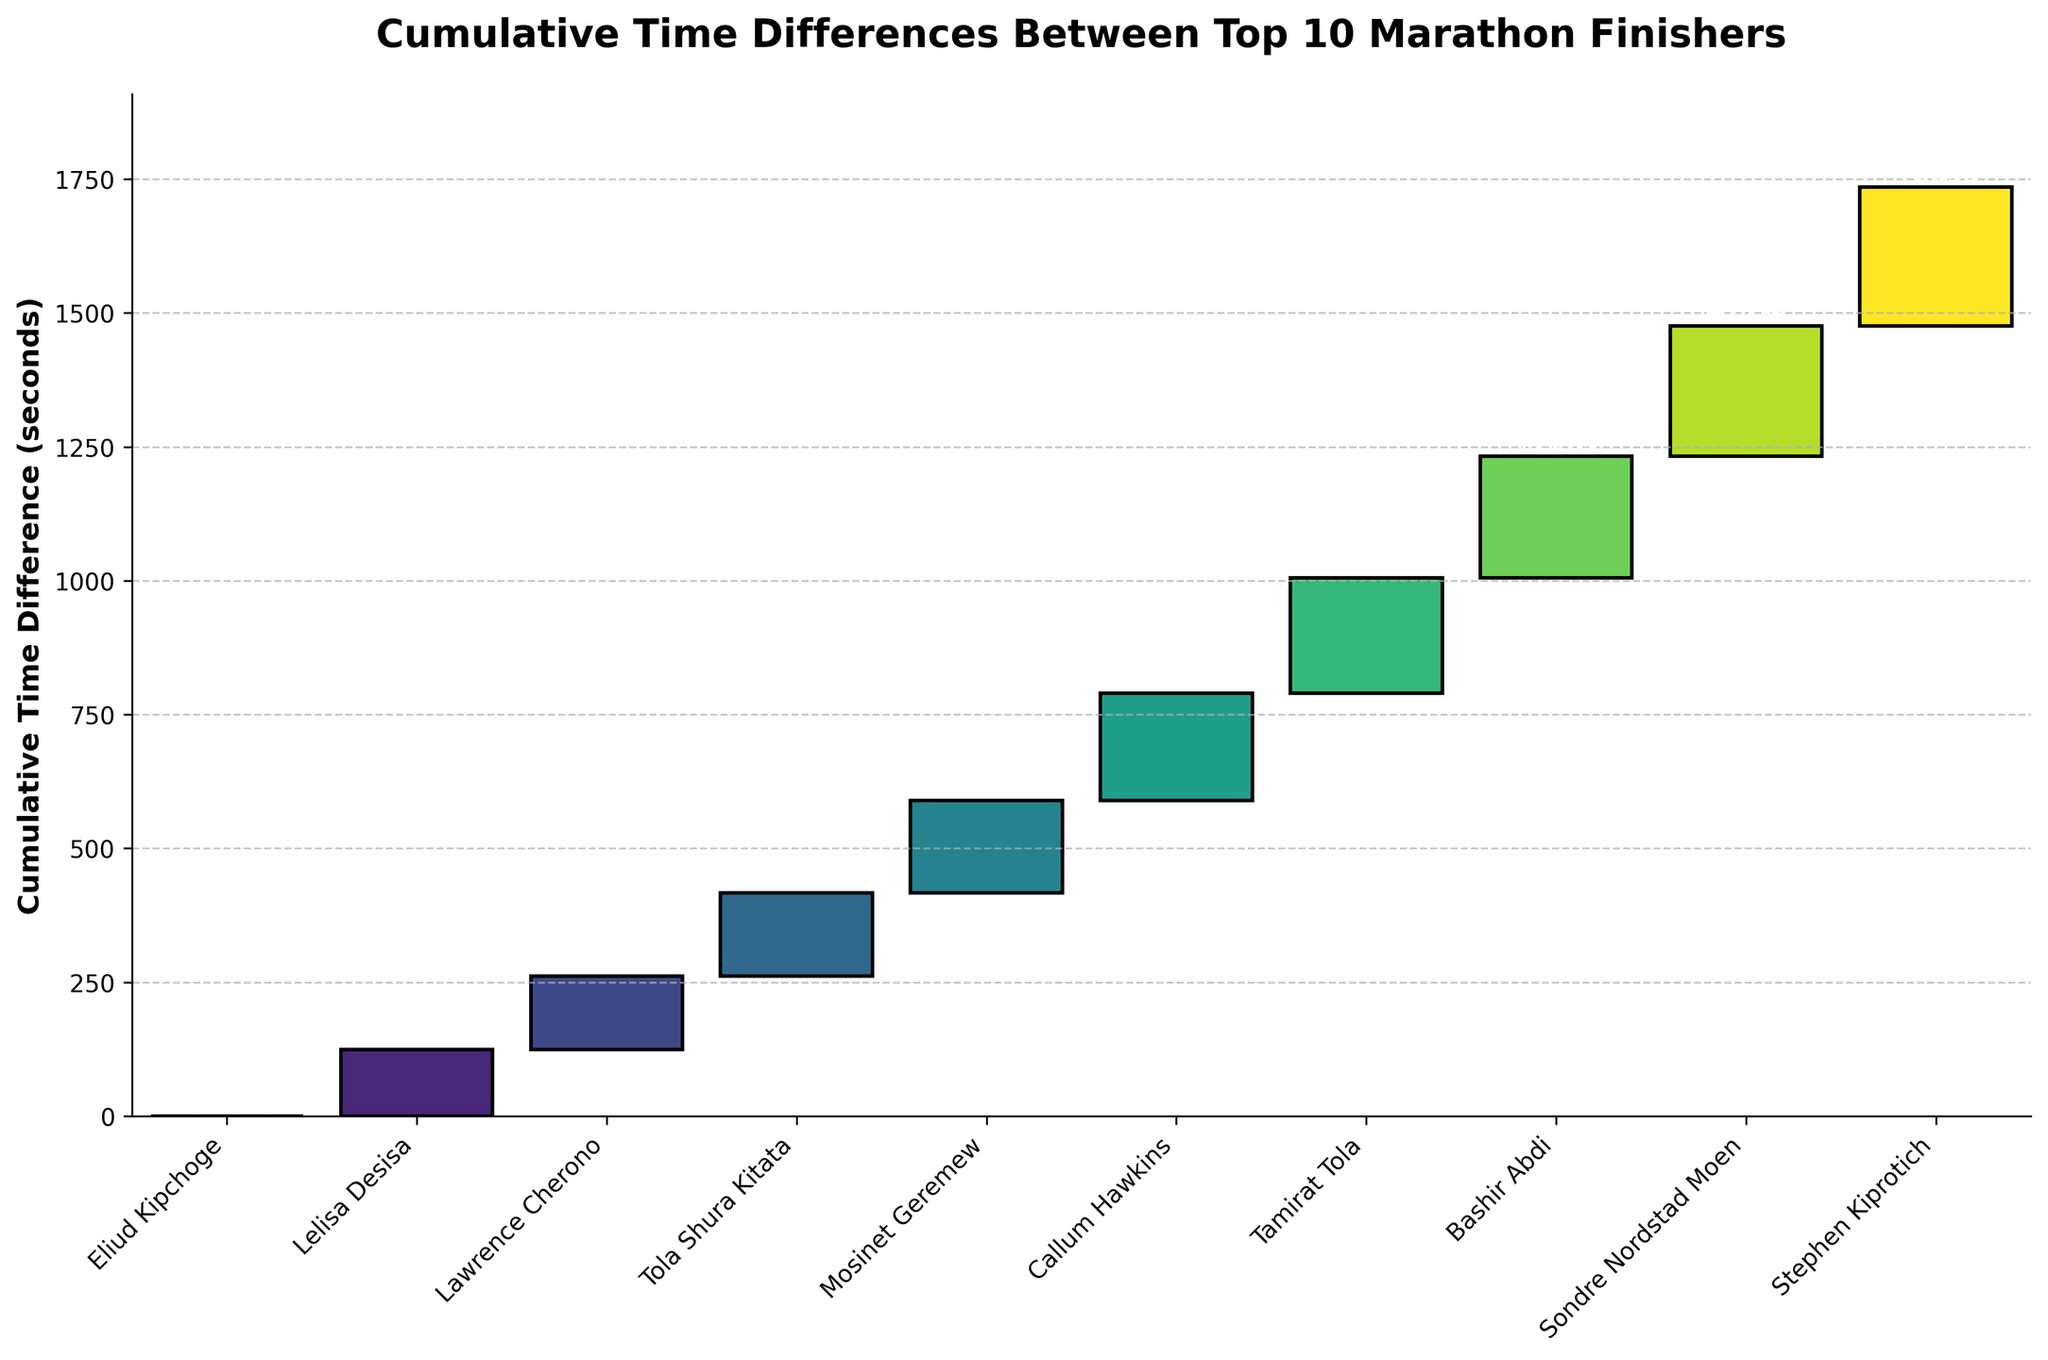What's the title of the figure? The title is visible at the top of the figure and provides a summary of what the chart represents.
Answer: Cumulative Time Differences Between Top 10 Marathon Finishers How many runners are shown in the chart? The number of runners is indicated by the number of bars in the waterfall chart.
Answer: 10 What is the y-axis label? The y-axis label describes what the vertical axis represents.
Answer: Cumulative Time Difference (seconds) Which runner finished second, and what was their time difference? Identify the second bar from the left and the label and value associated with it. The second bar represents the runner who finished second.
Answer: Lelisa Desisa, +124 seconds What is the time difference between 1st and 3rd place? Compare the time difference values of the 1st and 3rd runners. First-place is 0 seconds, third-place is +137 seconds.
Answer: +137 seconds What's the cumulative time difference for the runner who finished 5th? Sum the values from the 1st to the 5th runner. The cumulative difference for the 5th runner, Mosinet Geremew, adds up all the differences leading to him. 0 + 124 + 137 + 156 + 172 = 589 seconds.
Answer: 589 seconds Who had the largest single time difference from the previous runner, and what was it? Look for the largest difference value between consecutive bars. Callum Hawkins has a difference of +201 seconds.
Answer: Callum Hawkins, +201 seconds What is the average cumulative time difference for the top 10 runners? Calculate the total cumulative difference for all runners and divide by the number of runners. Total cumulative difference: 0 + 124 + 137 + 156 + 172 + 201 + 215 + 228 + 243 + 259 = 1735 seconds. Average = 1735/10 = 173.5 seconds.
Answer: 173.5 seconds What's the total cumulative time difference for all runners? Add up the cumulative time differences for all runners.
Answer: 1735 seconds Which runner has a cumulative time difference closest to 200 seconds? Identify the runner whose cumulative time difference value is nearest to 200. Callum Hawkins has a difference of +201 seconds, which is closest to 200.
Answer: Callum Hawkins 